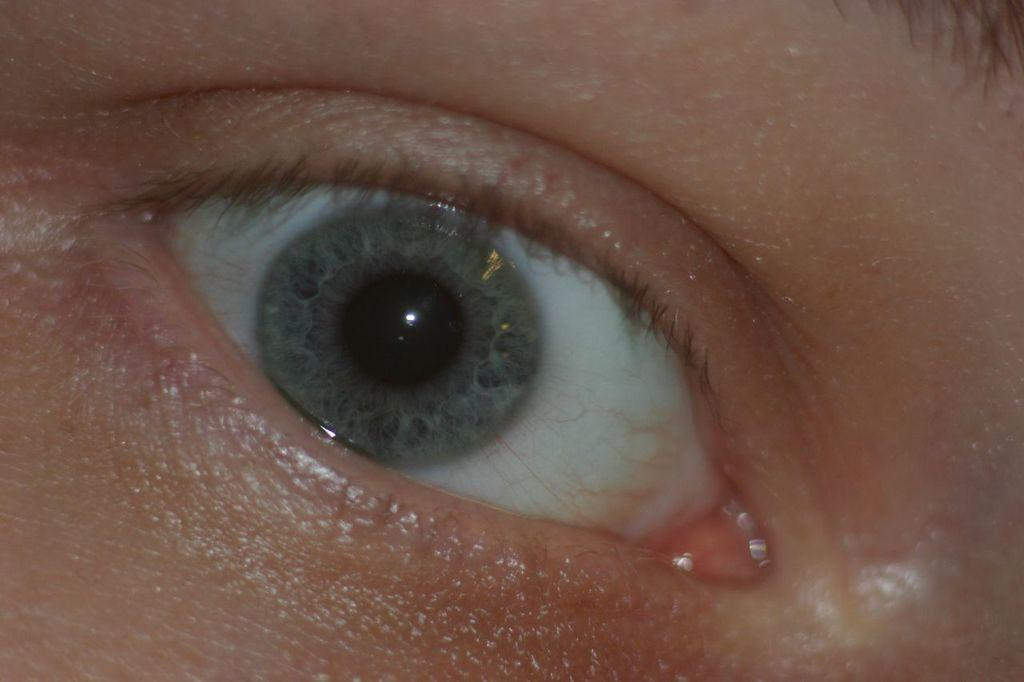What is the main subject of the image? The main subject of the image is a person's eye. What type of owl can be seen in the person's eye in the image? There is no owl present in the person's eye or the image. 